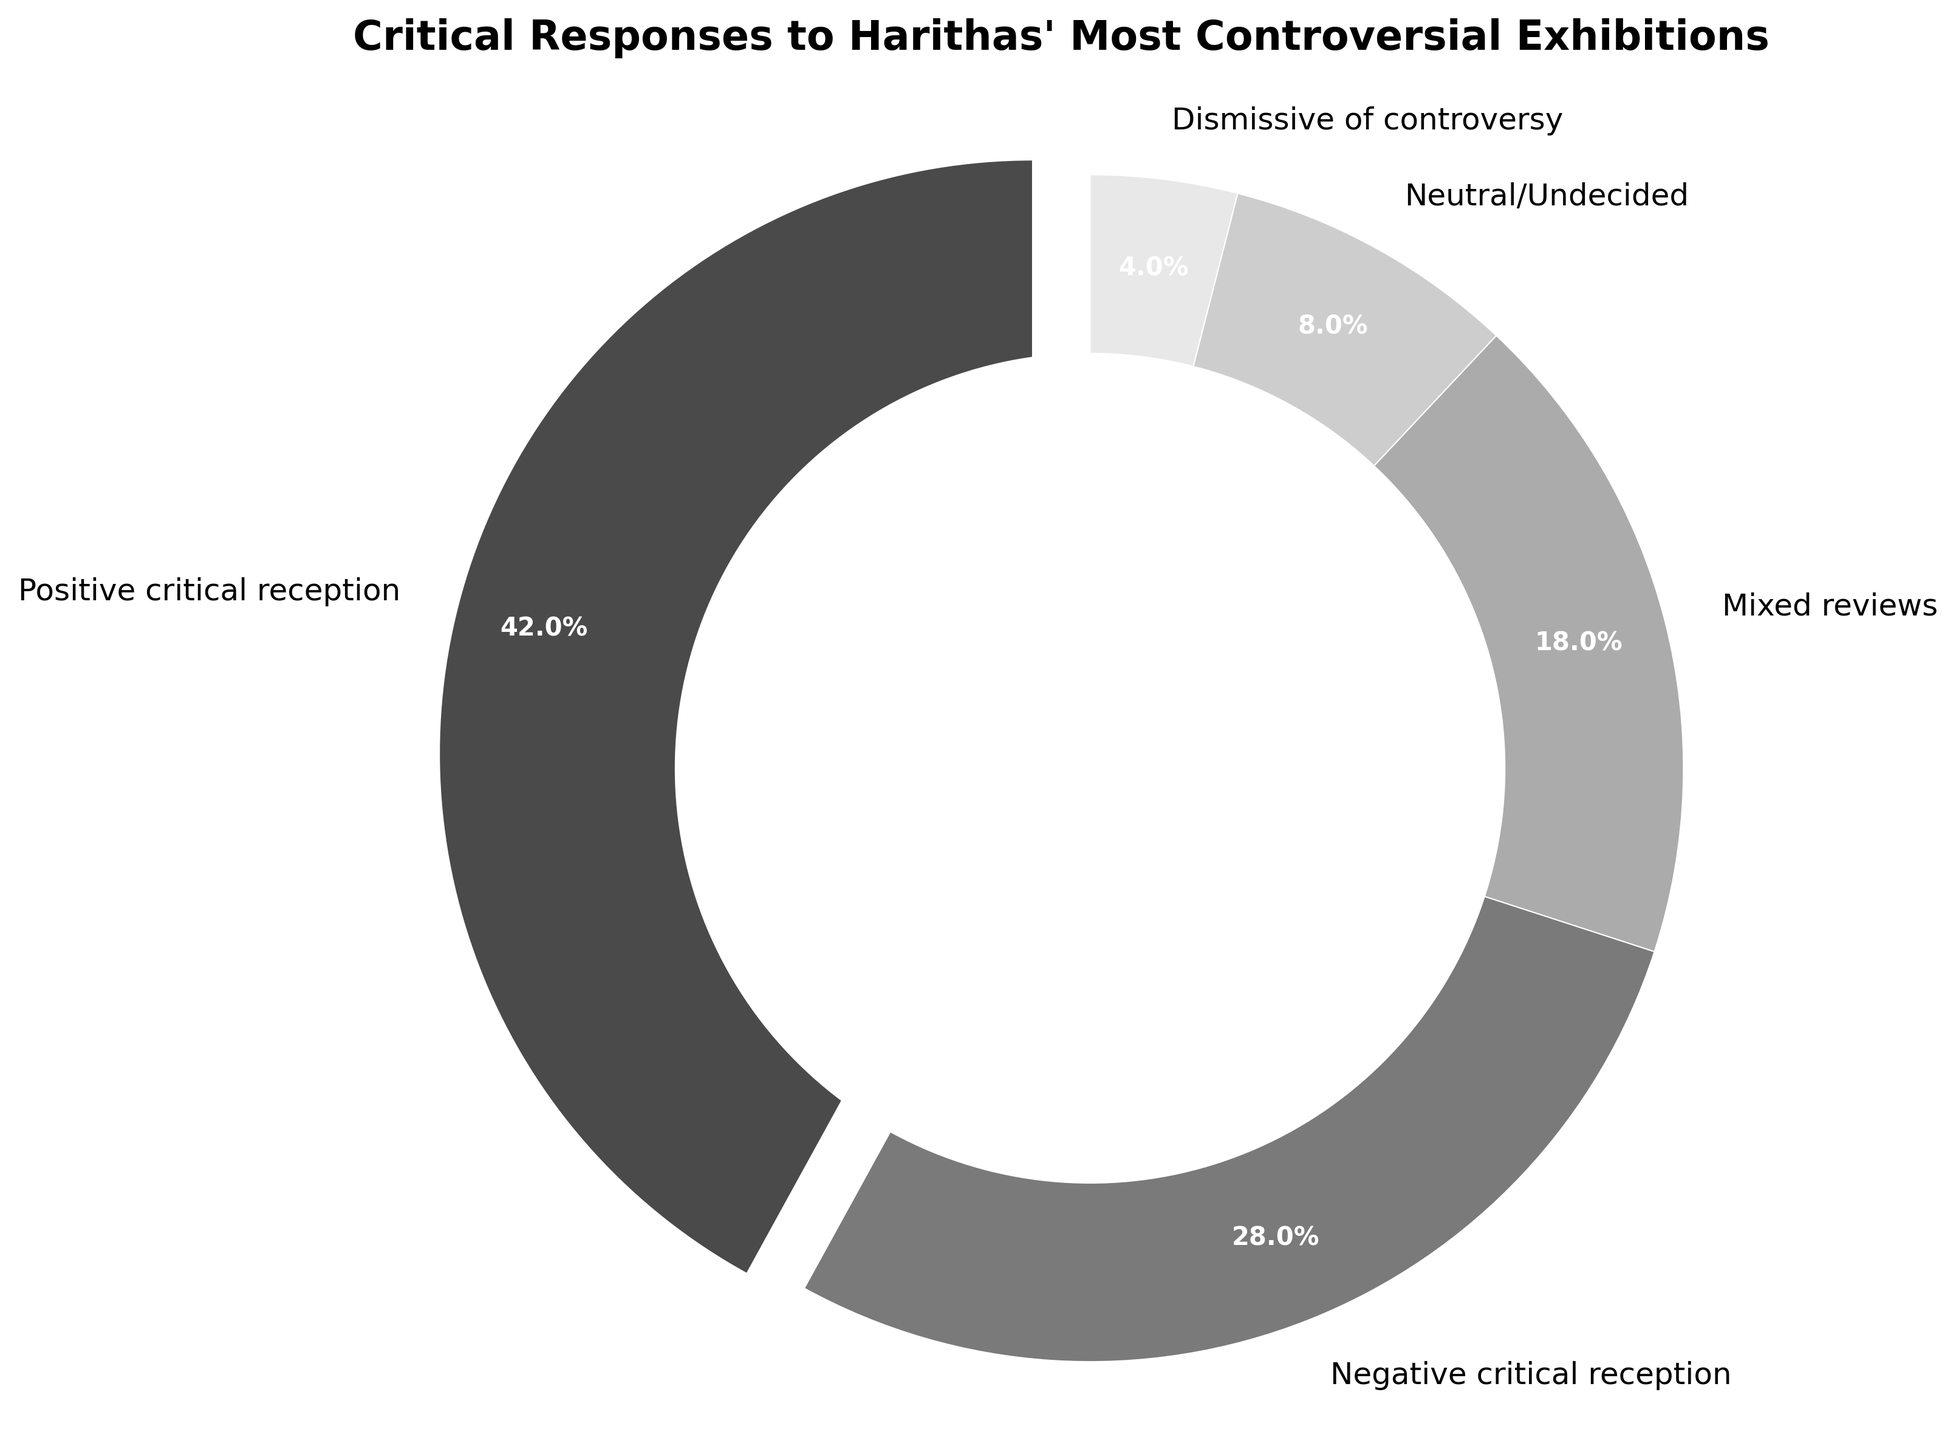What percentage of the responses were positive? The "Positive critical reception" segment shows the percentage directly on the pie chart.
Answer: 42% How many responses were either negative or dismissive? The combined percentage of "Negative critical reception" and "Dismissive of controversy" is obtained by adding their respective percentages: 28% + 4%.
Answer: 32% Which category received the least amount of critical response? By comparing the percentages in each segment, the "Dismissive of controversy" category has the smallest percentage.
Answer: Dismissive of controversy What is the difference between the positive and negative critical receptions? Subtract the percentage of "Negative critical reception" from "Positive critical reception": 42% - 28%.
Answer: 14% What combined percentage of the responses were mixed or neutral? Sum the percentages for "Mixed reviews" and "Neutral/Undecided": 18% + 8%.
Answer: 26% If the pie chart had 100 responses total, how many responses were neutral or undecided? Multiply the total responses by the percentage of "Neutral/Undecided": 100 * 8% = 8/100 * 100.
Answer: 8 Compare the positive critical reception to the mixed reviews. Which is higher and by how much? The percentage of "Positive critical reception" is 42%, and "Mixed reviews" is 18%. 42% is higher than 18% by the difference: 42% - 18%.
Answer: Positive critical reception is higher by 24% What's double the percentage of dismissive responses? Multiply the percentage of "Dismissive of controversy" by 2: 4% * 2.
Answer: 8% How much more common were positive critical receptions than neutral or undecided responses? Subtract the percentage of "Neutral/Undecided" from "Positive critical reception": 42% - 8%.
Answer: 34% What is the most frequent type of critical reception? By comparing all percentages, the "Positive critical reception" segment has the highest percentage.
Answer: Positive critical reception 